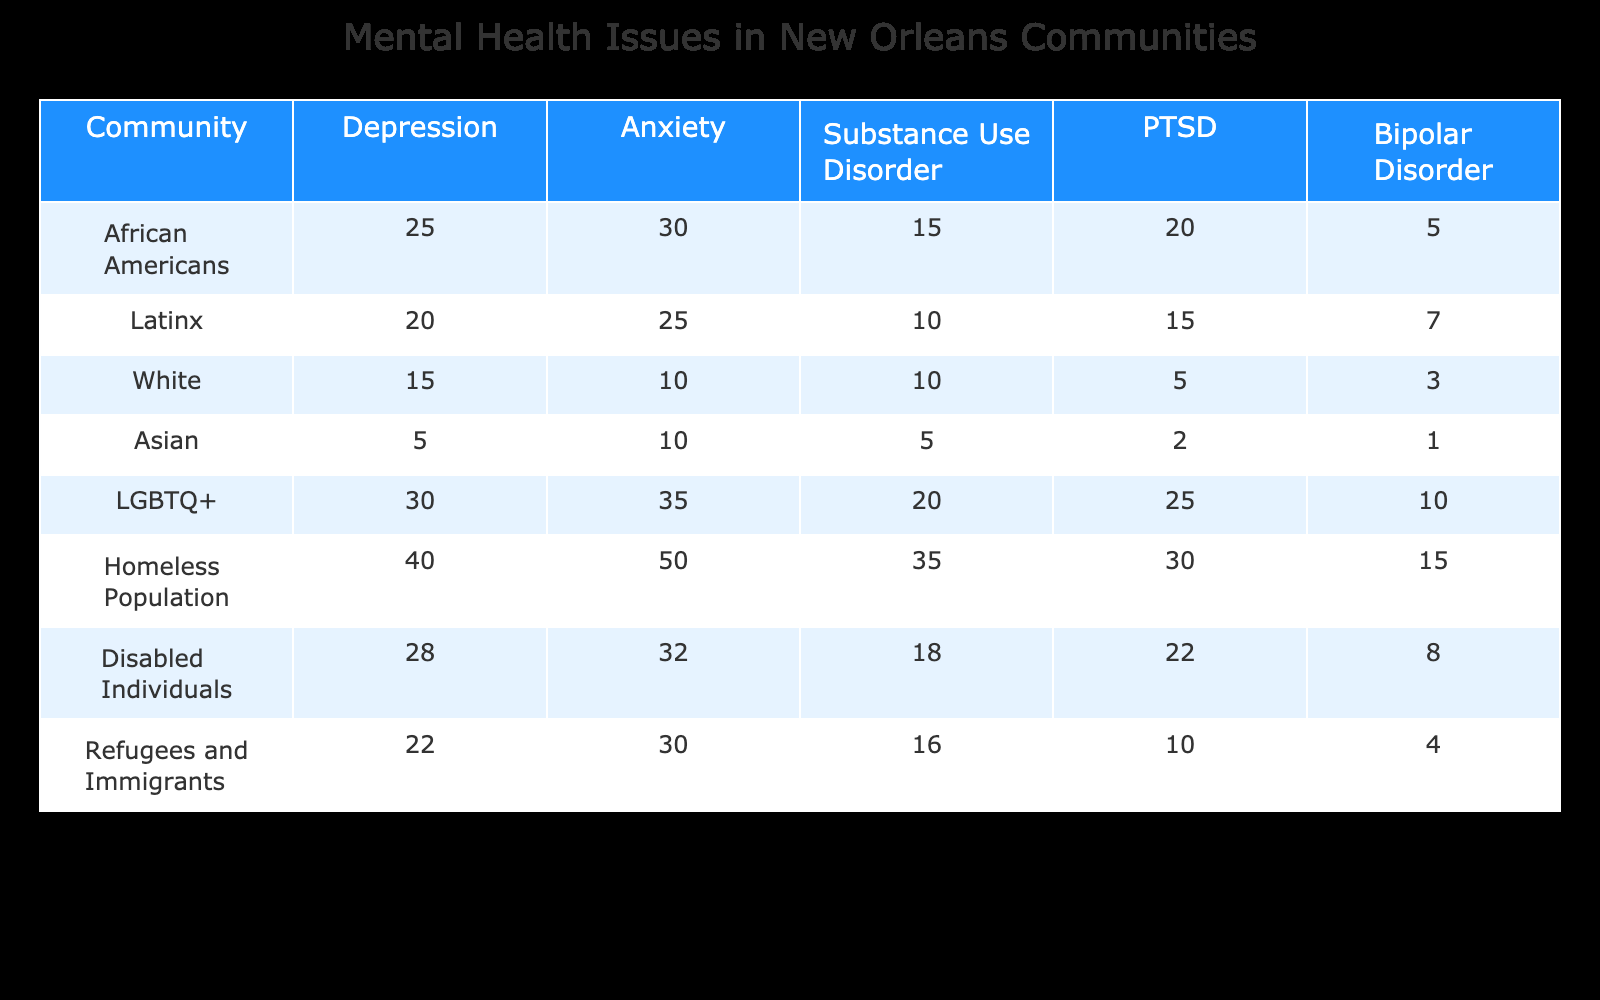What community has the highest reported rate of anxiety issues? Looking at the anxiety column, the highest value is 50, which corresponds to the Homeless Population.
Answer: Homeless Population What is the total number of substance use disorder cases reported by African Americans and Disabled Individuals combined? African Americans report 15 cases and Disabled Individuals report 18 cases. Adding these gives 15 + 18 = 33.
Answer: 33 Is the rate of PTSD higher in the LGBTQ+ community compared to the Asian community? The LGBTQ+ community has a PTSD rate of 25, while the Asian community has a rate of 2. Since 25 is greater than 2, the statement is true.
Answer: Yes What is the average rate of bipolar disorder reported across all communities? To find the average, we sum the bipolar disorder rates: 5 + 7 + 3 + 1 + 10 + 15 + 8 + 4 = 49. There are 8 communities, so the average is 49/8 = 6.125.
Answer: 6.125 How many more cases of depression are reported by the Homeless Population compared to White individuals? The Homeless Population reports 40 cases of depression, while White individuals report 15 cases. The difference is 40 - 15 = 25.
Answer: 25 Does the Latinx community report more anxiety cases than the Disabled Individuals? The Latinx community reports 25 cases of anxiety and Disabled Individuals report 32. Since 25 is less than 32, this statement is false.
Answer: No What is the total number of mental health issues reported by the Disabled Individuals? To find the total, we add up the numbers in the Disabled Individuals row: 28 (depression) + 32 (anxiety) + 18 (substance use) + 22 (PTSD) + 8 (bipolar) = 108.
Answer: 108 Which community has the lowest rate of substance use disorder? In the substance use disorder column, the community with the lowest value is the White community, reporting 10 cases.
Answer: White What percentage of total bipolar disorder cases are reported by the LGBTQ+ community? First, we find the total number of bipolar disorder cases: 5 + 7 + 3 + 1 + 10 + 15 + 8 + 4 = 49. The LGBTQ+ community reports 10 cases. To find the percentage, (10/49) * 100 ≈ 20.41%.
Answer: 20.41% 